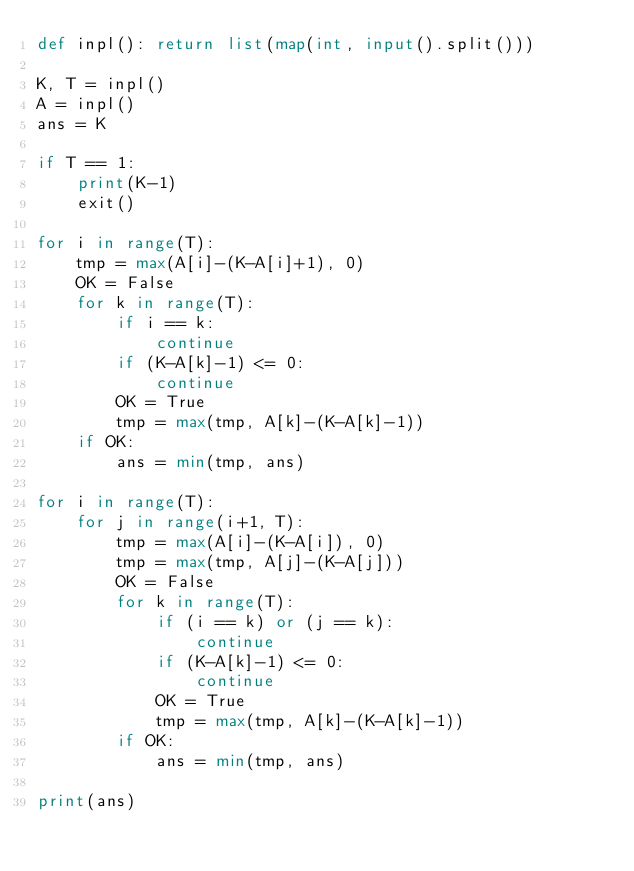<code> <loc_0><loc_0><loc_500><loc_500><_Python_>def inpl(): return list(map(int, input().split()))

K, T = inpl()
A = inpl()
ans = K

if T == 1:
    print(K-1)
    exit()

for i in range(T):
    tmp = max(A[i]-(K-A[i]+1), 0)
    OK = False
    for k in range(T):
        if i == k:
            continue
        if (K-A[k]-1) <= 0:
            continue
        OK = True
        tmp = max(tmp, A[k]-(K-A[k]-1))
    if OK:
        ans = min(tmp, ans)

for i in range(T):
    for j in range(i+1, T):
        tmp = max(A[i]-(K-A[i]), 0)
        tmp = max(tmp, A[j]-(K-A[j]))
        OK = False
        for k in range(T):
            if (i == k) or (j == k):
                continue
            if (K-A[k]-1) <= 0:
                continue
            OK = True
            tmp = max(tmp, A[k]-(K-A[k]-1))
        if OK:
            ans = min(tmp, ans)

print(ans)</code> 